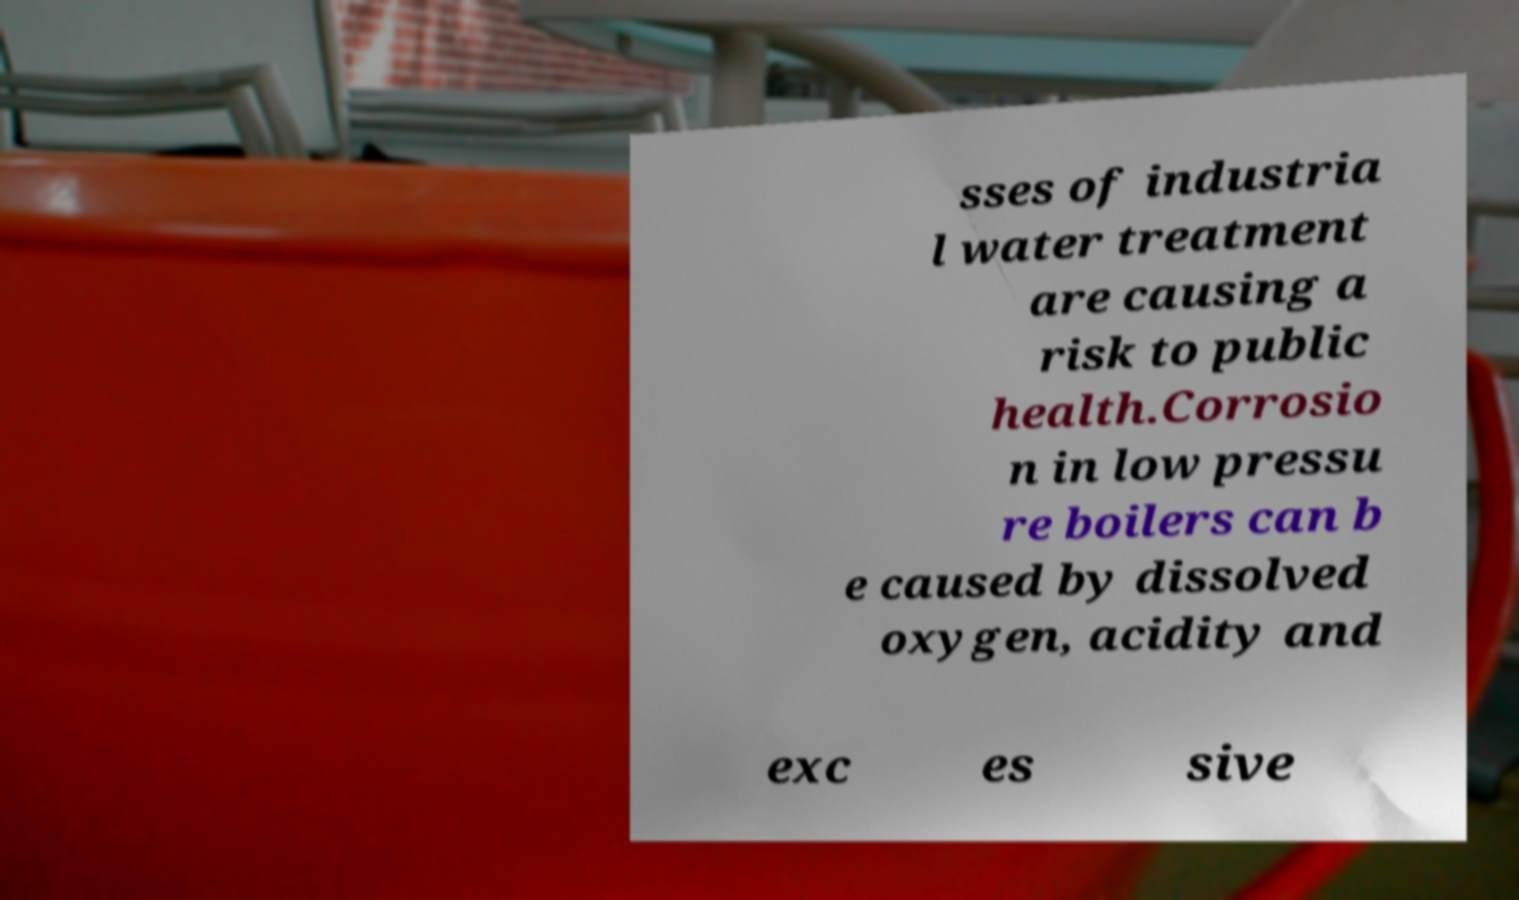Could you assist in decoding the text presented in this image and type it out clearly? sses of industria l water treatment are causing a risk to public health.Corrosio n in low pressu re boilers can b e caused by dissolved oxygen, acidity and exc es sive 